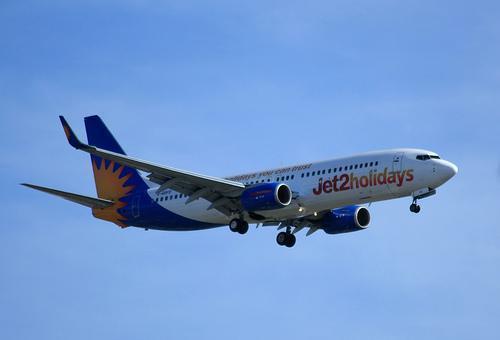How many windows are to the left of the wing?
Give a very brief answer. 8. 